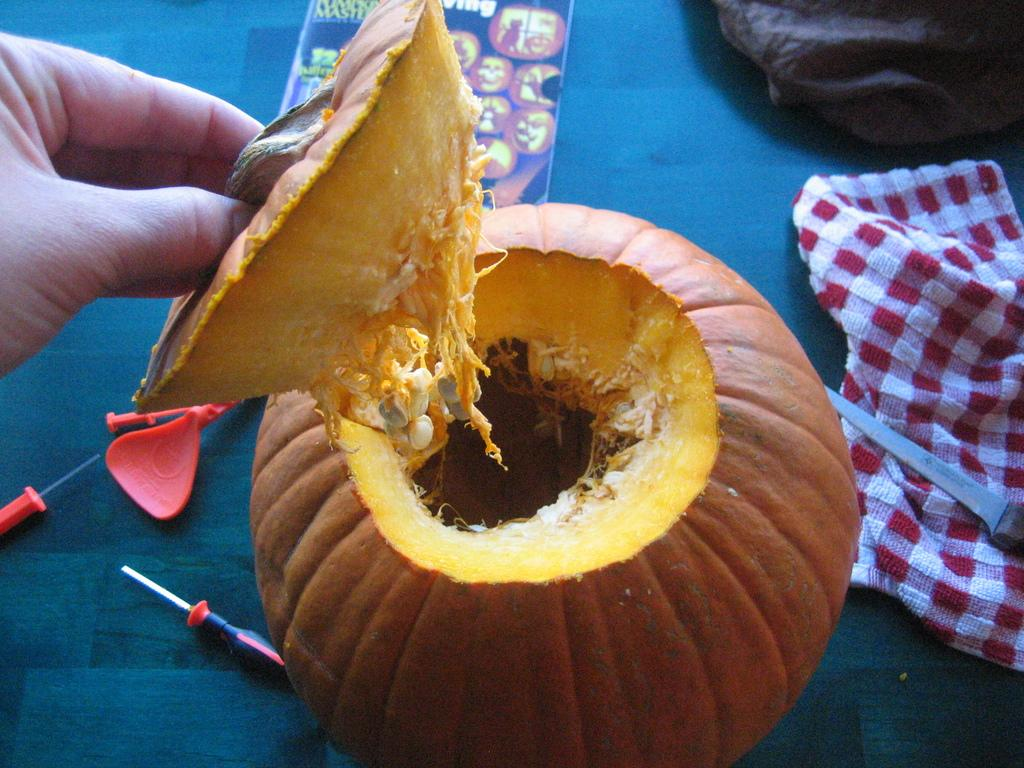What is the person holding in the image? There is a piece of pumpkin in the hand of a person. What objects can be seen in the image besides the pumpkin? There are pins and a knife visible in the image. What else is present in the image? There are clothes and a pumpkin on the table in the image. What type of punishment is being administered to the rabbit in the image? There is no rabbit present in the image, and therefore no punishment can be observed. What knowledge can be gained from the image? The image does not convey any specific knowledge or information beyond the objects and subjects present. 